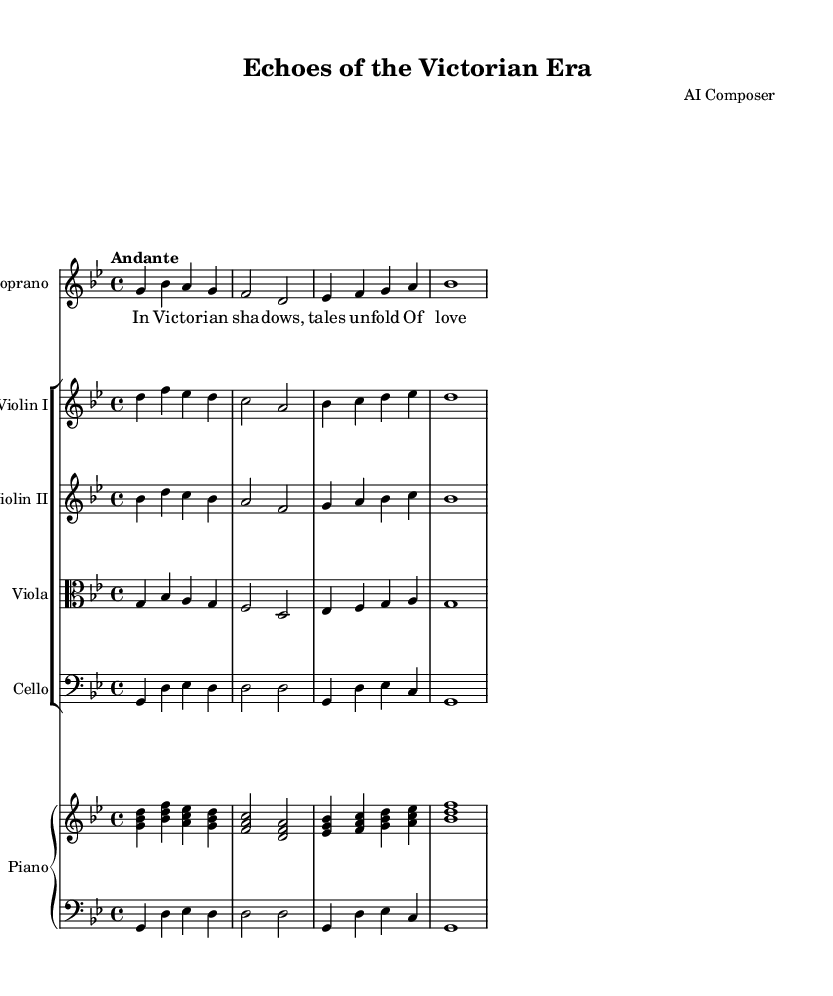What is the key signature of this music? The key signature is G minor, which has two flats: B flat and E flat. This can be determined by looking at the key signature notations at the beginning of the staff.
Answer: G minor What is the time signature of this music? The time signature is 4/4, which indicates there are four beats in a measure and the quarter note gets one beat. This is visible in the notation at the start of the score.
Answer: 4/4 What is the tempo marking indicated in this piece? The tempo marking is "Andante," which means to play at a moderately slow speed. The tempo is specified near the beginning of the piece, providing guidance on the overall pace of the music.
Answer: Andante How many instruments are there in this score? There are six instruments in total: Soprano, Violin I, Violin II, Viola, Cello, and Piano. This can be confirmed by counting the distinct staves present in the score.
Answer: Six What is the name of the vocal part in this music? The vocal part is labeled "Soprano," which is the highest female voice category in opera. This label is found at the top of the staff where the soprano's music is written.
Answer: Soprano Which historical period is reflected in the theme of this opera? The theme of this opera reflects the Victorian Era, which is suggested by the title "Echoes of the Victorian Era." This can be inferred from the title and the corresponding lyrics of the piece that evoke that time period.
Answer: Victorian Era What is the mood conveyed in the lyrics of this opera? The mood conveyed in the lyrics is one of nostalgia, encompassing themes of love and loss, which is evident from the words "In Victorian shadows, tales unfold." This highlights emotional depth and historical reflection.
Answer: Nostalgia 